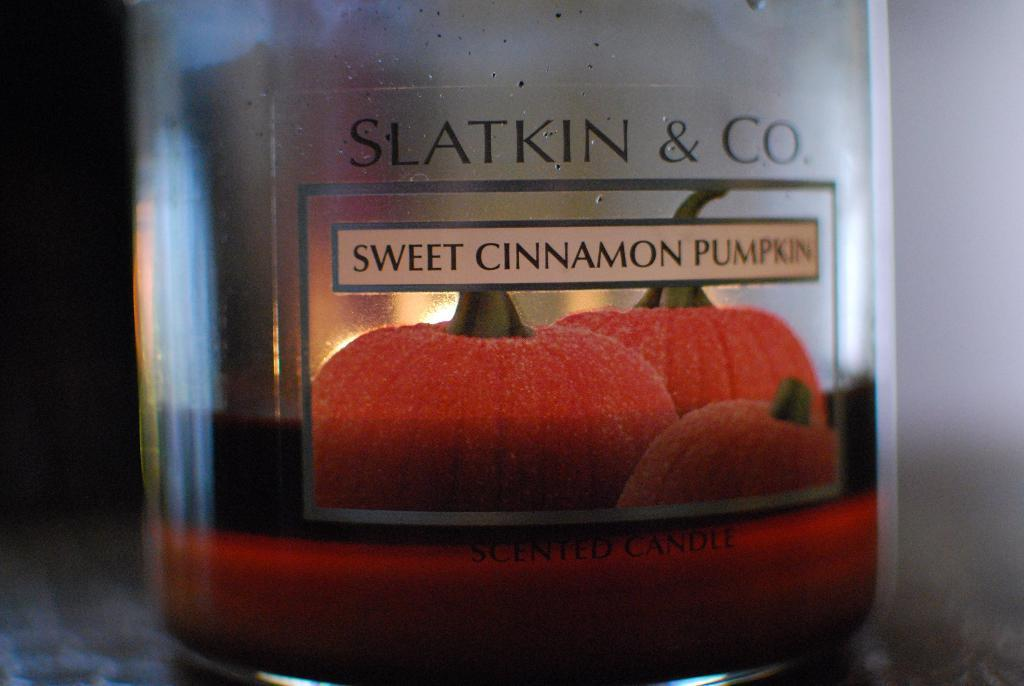What object is present in the image that can hold a liquid? There is a glass in the image that can hold a liquid. What is inside the glass in the image? There is a candle in the glass. Where is the farmer standing in the image? There is no farmer present in the image. What type of rail is visible in the image? There is no rail present in the image. 